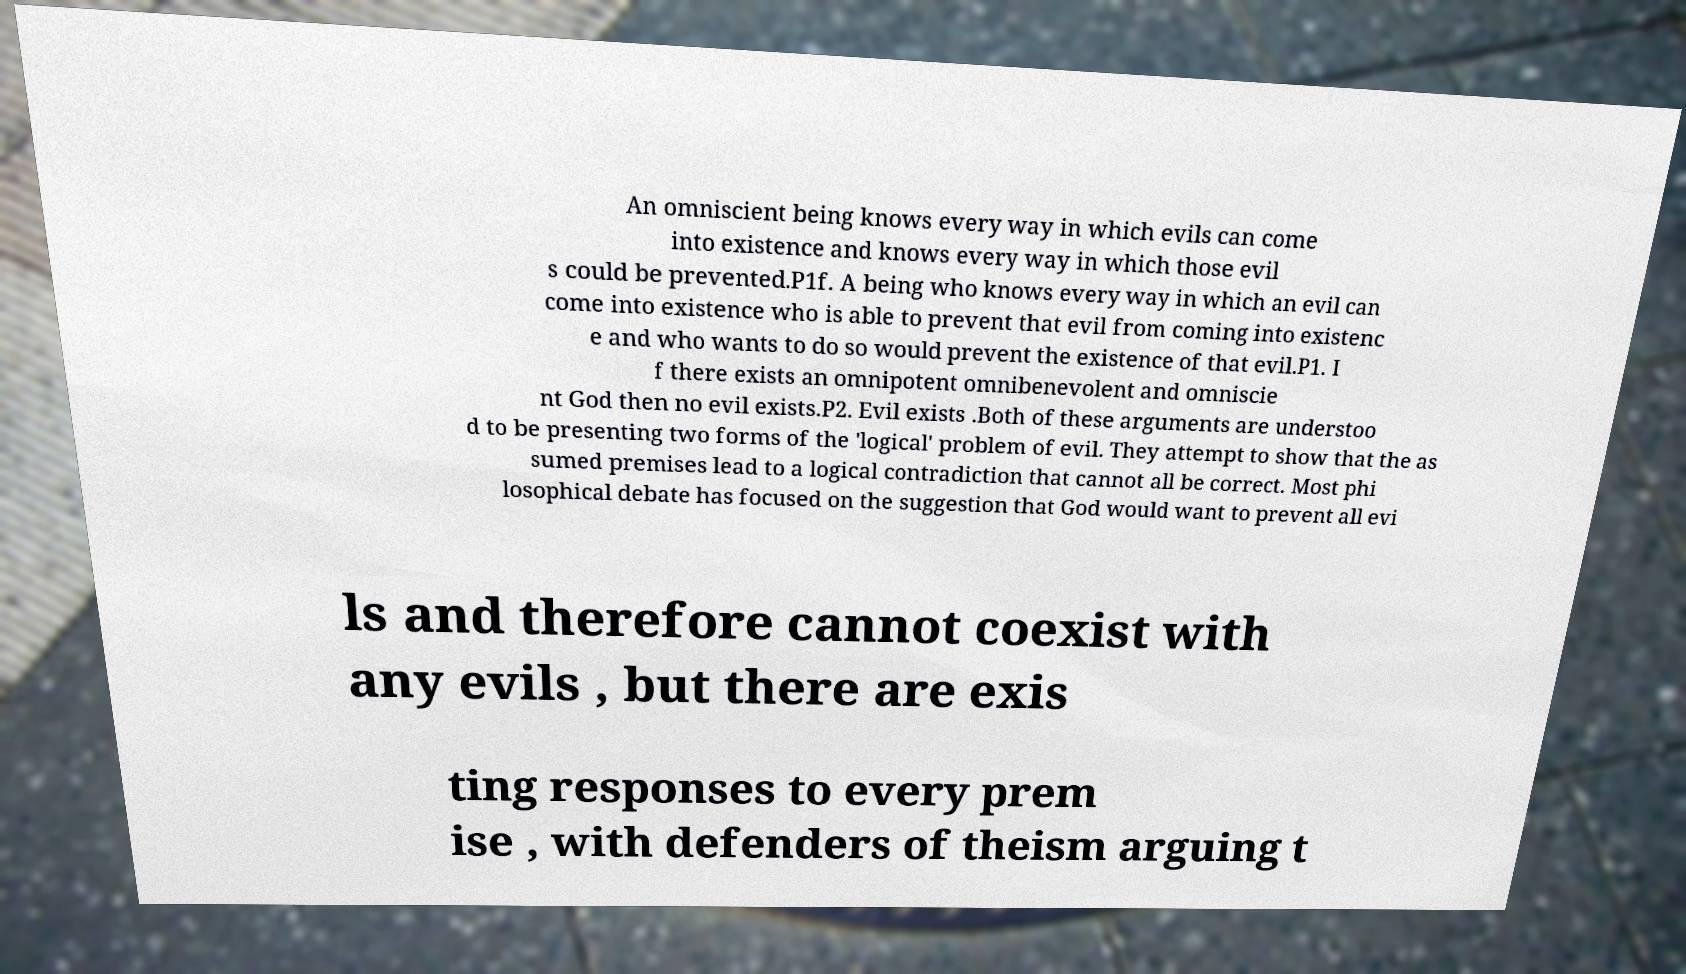For documentation purposes, I need the text within this image transcribed. Could you provide that? An omniscient being knows every way in which evils can come into existence and knows every way in which those evil s could be prevented.P1f. A being who knows every way in which an evil can come into existence who is able to prevent that evil from coming into existenc e and who wants to do so would prevent the existence of that evil.P1. I f there exists an omnipotent omnibenevolent and omniscie nt God then no evil exists.P2. Evil exists .Both of these arguments are understoo d to be presenting two forms of the 'logical' problem of evil. They attempt to show that the as sumed premises lead to a logical contradiction that cannot all be correct. Most phi losophical debate has focused on the suggestion that God would want to prevent all evi ls and therefore cannot coexist with any evils , but there are exis ting responses to every prem ise , with defenders of theism arguing t 